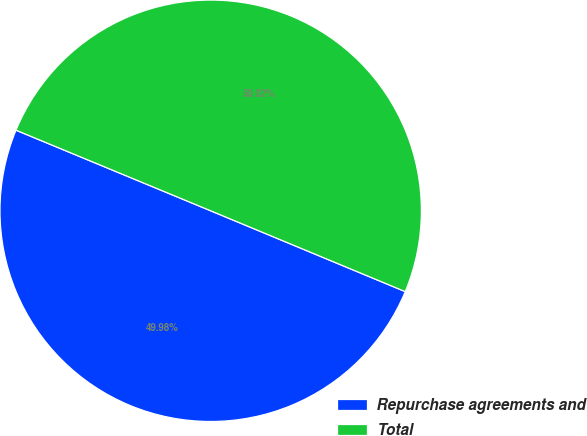Convert chart. <chart><loc_0><loc_0><loc_500><loc_500><pie_chart><fcel>Repurchase agreements and<fcel>Total<nl><fcel>49.98%<fcel>50.02%<nl></chart> 